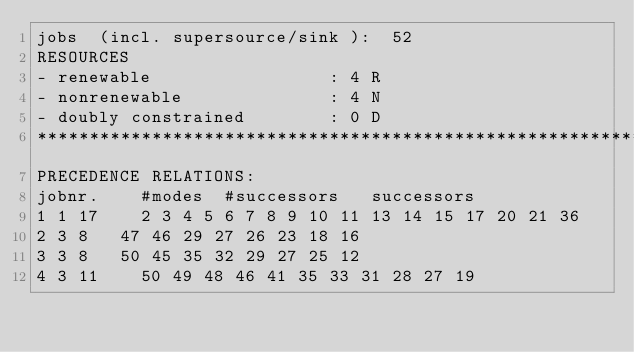Convert code to text. <code><loc_0><loc_0><loc_500><loc_500><_ObjectiveC_>jobs  (incl. supersource/sink ):	52
RESOURCES
- renewable                 : 4 R
- nonrenewable              : 4 N
- doubly constrained        : 0 D
************************************************************************
PRECEDENCE RELATIONS:
jobnr.    #modes  #successors   successors
1	1	17		2 3 4 5 6 7 8 9 10 11 13 14 15 17 20 21 36 
2	3	8		47 46 29 27 26 23 18 16 
3	3	8		50 45 35 32 29 27 25 12 
4	3	11		50 49 48 46 41 35 33 31 28 27 19 </code> 